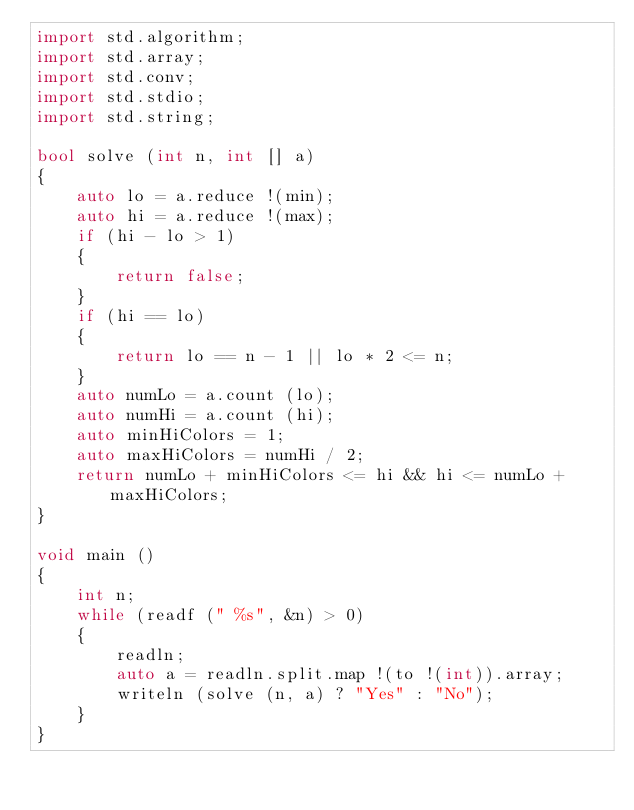<code> <loc_0><loc_0><loc_500><loc_500><_D_>import std.algorithm;
import std.array;
import std.conv;
import std.stdio;
import std.string;

bool solve (int n, int [] a)
{
	auto lo = a.reduce !(min);
	auto hi = a.reduce !(max);
	if (hi - lo > 1)
	{
		return false;
	}
	if (hi == lo)
	{
		return lo == n - 1 || lo * 2 <= n;
	}
	auto numLo = a.count (lo);
	auto numHi = a.count (hi);
	auto minHiColors = 1;
	auto maxHiColors = numHi / 2;
	return numLo + minHiColors <= hi && hi <= numLo + maxHiColors;
}

void main ()
{
	int n;
	while (readf (" %s", &n) > 0)
	{
		readln;
		auto a = readln.split.map !(to !(int)).array;
		writeln (solve (n, a) ? "Yes" : "No");
	}
}
</code> 